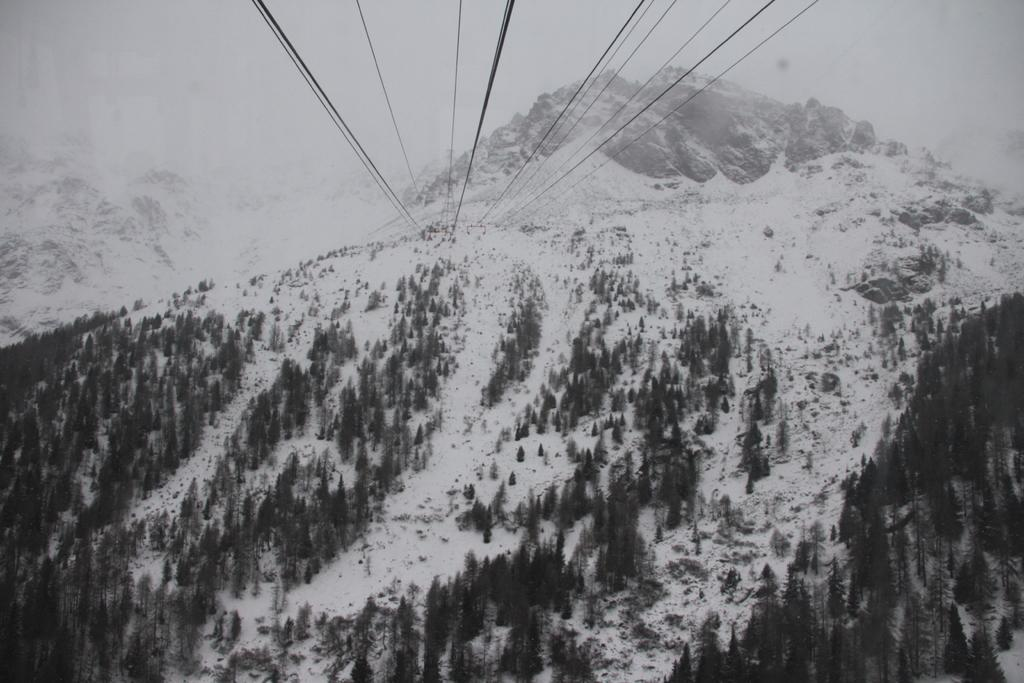What is the main feature of the picture? There is an ice mountain in the picture. What type of vegetation is near the ice mountain? There are long trees near the ice mountain. What can be seen in the distance behind the ice mountain? There are mountains visible in the background. What is present above the mountains in the image? There are cables visible above the mountains. Can you see a robin perched on the ice mountain in the image? There is no robin present in the image. What type of plant is growing on the ice mountain in the image? There are no plants growing on the ice mountain in the image. 